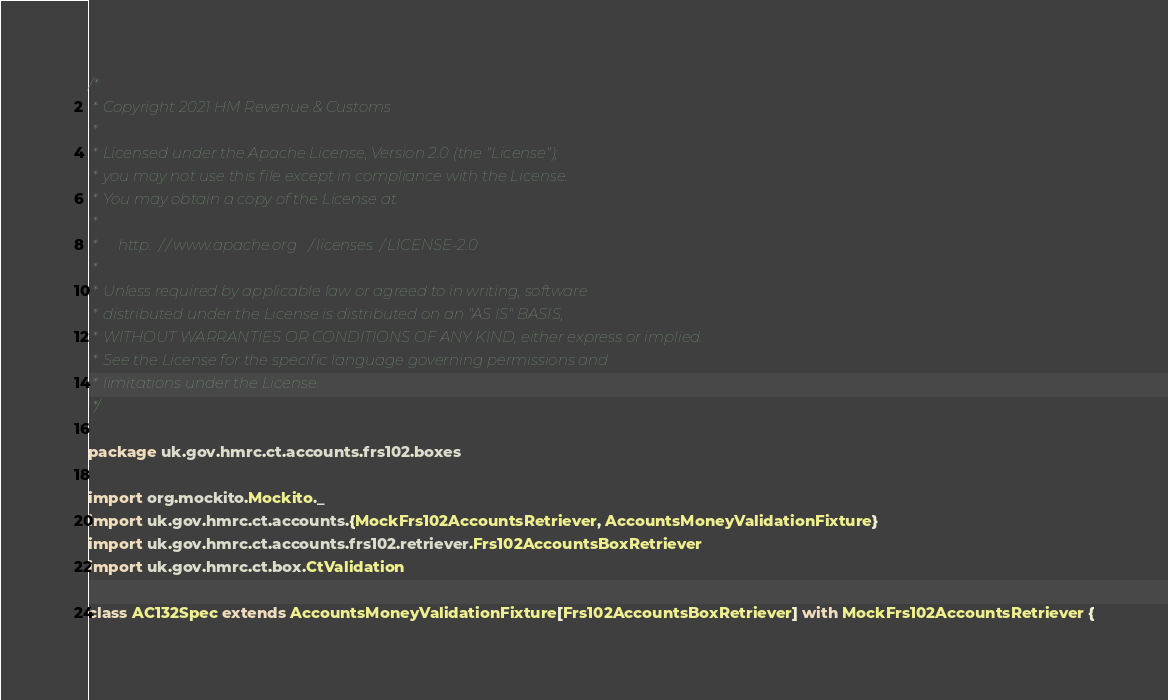Convert code to text. <code><loc_0><loc_0><loc_500><loc_500><_Scala_>/*
 * Copyright 2021 HM Revenue & Customs
 *
 * Licensed under the Apache License, Version 2.0 (the "License");
 * you may not use this file except in compliance with the License.
 * You may obtain a copy of the License at
 *
 *     http://www.apache.org/licenses/LICENSE-2.0
 *
 * Unless required by applicable law or agreed to in writing, software
 * distributed under the License is distributed on an "AS IS" BASIS,
 * WITHOUT WARRANTIES OR CONDITIONS OF ANY KIND, either express or implied.
 * See the License for the specific language governing permissions and
 * limitations under the License.
 */

package uk.gov.hmrc.ct.accounts.frs102.boxes

import org.mockito.Mockito._
import uk.gov.hmrc.ct.accounts.{MockFrs102AccountsRetriever, AccountsMoneyValidationFixture}
import uk.gov.hmrc.ct.accounts.frs102.retriever.Frs102AccountsBoxRetriever
import uk.gov.hmrc.ct.box.CtValidation

class AC132Spec extends AccountsMoneyValidationFixture[Frs102AccountsBoxRetriever] with MockFrs102AccountsRetriever {
</code> 